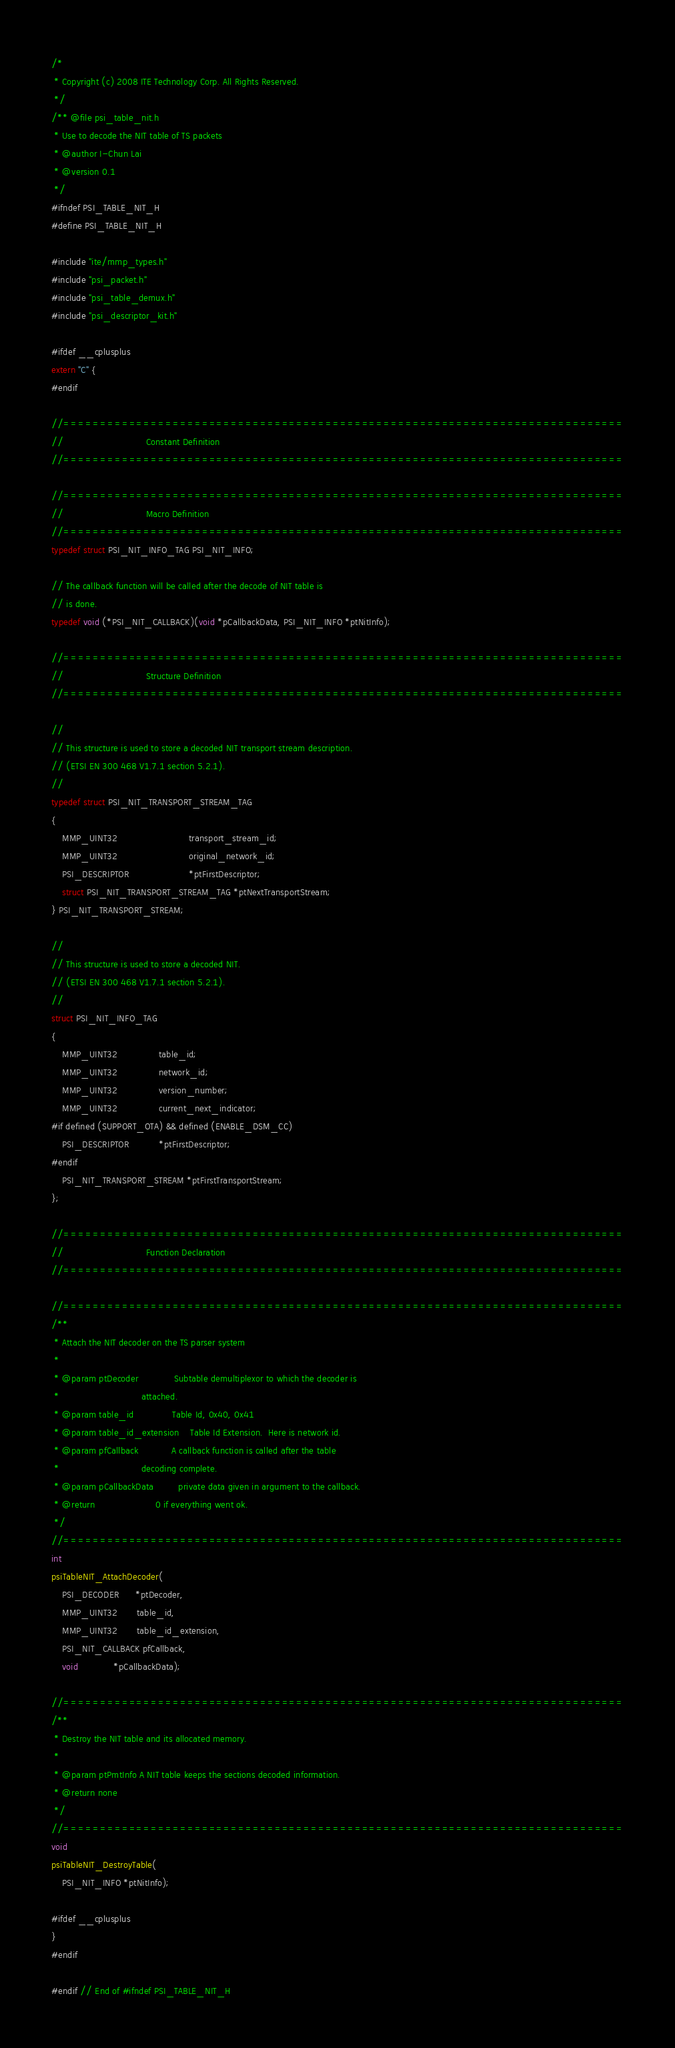<code> <loc_0><loc_0><loc_500><loc_500><_C_>/*
 * Copyright (c) 2008 ITE Technology Corp. All Rights Reserved.
 */
/** @file psi_table_nit.h
 * Use to decode the NIT table of TS packets
 * @author I-Chun Lai
 * @version 0.1
 */
#ifndef PSI_TABLE_NIT_H
#define PSI_TABLE_NIT_H

#include "ite/mmp_types.h"
#include "psi_packet.h"
#include "psi_table_demux.h"
#include "psi_descriptor_kit.h"

#ifdef __cplusplus
extern "C" {
#endif

//=============================================================================
//                              Constant Definition
//=============================================================================

//=============================================================================
//                              Macro Definition
//=============================================================================
typedef struct PSI_NIT_INFO_TAG PSI_NIT_INFO;

// The callback function will be called after the decode of NIT table is
// is done.
typedef void (*PSI_NIT_CALLBACK)(void *pCallbackData, PSI_NIT_INFO *ptNitInfo);

//=============================================================================
//                              Structure Definition
//=============================================================================

//
// This structure is used to store a decoded NIT transport stream description.
// (ETSI EN 300 468 V1.7.1 section 5.2.1).
//
typedef struct PSI_NIT_TRANSPORT_STREAM_TAG
{
    MMP_UINT32                          transport_stream_id;
    MMP_UINT32                          original_network_id;
    PSI_DESCRIPTOR                      *ptFirstDescriptor;
    struct PSI_NIT_TRANSPORT_STREAM_TAG *ptNextTransportStream;
} PSI_NIT_TRANSPORT_STREAM;

//
// This structure is used to store a decoded NIT.
// (ETSI EN 300 468 V1.7.1 section 5.2.1).
//
struct PSI_NIT_INFO_TAG
{
    MMP_UINT32               table_id;
    MMP_UINT32               network_id;
    MMP_UINT32               version_number;
    MMP_UINT32               current_next_indicator;
#if defined (SUPPORT_OTA) && defined (ENABLE_DSM_CC)
    PSI_DESCRIPTOR           *ptFirstDescriptor;
#endif
    PSI_NIT_TRANSPORT_STREAM *ptFirstTransportStream;
};

//=============================================================================
//                              Function Declaration
//=============================================================================

//=============================================================================
/**
 * Attach the NIT decoder on the TS parser system
 *
 * @param ptDecoder             Subtable demultiplexor to which the decoder is
 *                              attached.
 * @param table_id              Table Id, 0x40, 0x41
 * @param table_id_extension    Table Id Extension.  Here is network id.
 * @param pfCallback            A callback function is called after the table
 *                              decoding complete.
 * @param pCallbackData         private data given in argument to the callback.
 * @return                      0 if everything went ok.
 */
//=============================================================================
int
psiTableNIT_AttachDecoder(
    PSI_DECODER      *ptDecoder,
    MMP_UINT32       table_id,
    MMP_UINT32       table_id_extension,
    PSI_NIT_CALLBACK pfCallback,
    void             *pCallbackData);

//=============================================================================
/**
 * Destroy the NIT table and its allocated memory.
 *
 * @param ptPmtInfo A NIT table keeps the sections decoded information.
 * @return none
 */
//=============================================================================
void
psiTableNIT_DestroyTable(
    PSI_NIT_INFO *ptNitInfo);

#ifdef __cplusplus
}
#endif

#endif // End of #ifndef PSI_TABLE_NIT_H</code> 